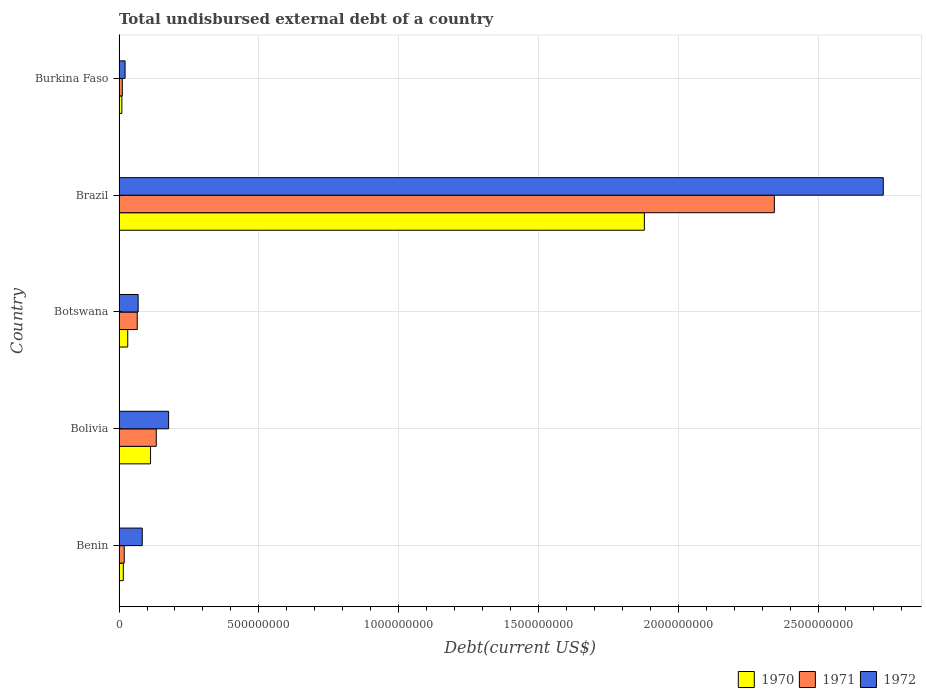How many groups of bars are there?
Provide a short and direct response. 5. Are the number of bars on each tick of the Y-axis equal?
Ensure brevity in your answer.  Yes. What is the label of the 3rd group of bars from the top?
Provide a short and direct response. Botswana. In how many cases, is the number of bars for a given country not equal to the number of legend labels?
Offer a very short reply. 0. What is the total undisbursed external debt in 1970 in Bolivia?
Your answer should be compact. 1.13e+08. Across all countries, what is the maximum total undisbursed external debt in 1972?
Offer a very short reply. 2.73e+09. Across all countries, what is the minimum total undisbursed external debt in 1970?
Offer a very short reply. 1.01e+07. In which country was the total undisbursed external debt in 1972 minimum?
Offer a very short reply. Burkina Faso. What is the total total undisbursed external debt in 1972 in the graph?
Offer a very short reply. 3.08e+09. What is the difference between the total undisbursed external debt in 1971 in Benin and that in Bolivia?
Your answer should be very brief. -1.15e+08. What is the difference between the total undisbursed external debt in 1972 in Benin and the total undisbursed external debt in 1971 in Brazil?
Ensure brevity in your answer.  -2.26e+09. What is the average total undisbursed external debt in 1971 per country?
Provide a short and direct response. 5.14e+08. What is the difference between the total undisbursed external debt in 1970 and total undisbursed external debt in 1971 in Bolivia?
Provide a succinct answer. -2.06e+07. In how many countries, is the total undisbursed external debt in 1972 greater than 2300000000 US$?
Offer a very short reply. 1. What is the ratio of the total undisbursed external debt in 1972 in Benin to that in Burkina Faso?
Ensure brevity in your answer.  3.85. Is the total undisbursed external debt in 1972 in Botswana less than that in Burkina Faso?
Offer a terse response. No. Is the difference between the total undisbursed external debt in 1970 in Bolivia and Burkina Faso greater than the difference between the total undisbursed external debt in 1971 in Bolivia and Burkina Faso?
Make the answer very short. No. What is the difference between the highest and the second highest total undisbursed external debt in 1972?
Keep it short and to the point. 2.56e+09. What is the difference between the highest and the lowest total undisbursed external debt in 1972?
Provide a succinct answer. 2.71e+09. What does the 1st bar from the bottom in Burkina Faso represents?
Your answer should be compact. 1970. How many bars are there?
Offer a very short reply. 15. Are all the bars in the graph horizontal?
Offer a very short reply. Yes. How many countries are there in the graph?
Provide a short and direct response. 5. What is the difference between two consecutive major ticks on the X-axis?
Provide a succinct answer. 5.00e+08. Does the graph contain grids?
Give a very brief answer. Yes. Where does the legend appear in the graph?
Your response must be concise. Bottom right. How many legend labels are there?
Provide a short and direct response. 3. What is the title of the graph?
Give a very brief answer. Total undisbursed external debt of a country. What is the label or title of the X-axis?
Your answer should be compact. Debt(current US$). What is the label or title of the Y-axis?
Offer a terse response. Country. What is the Debt(current US$) in 1970 in Benin?
Offer a very short reply. 1.53e+07. What is the Debt(current US$) in 1971 in Benin?
Provide a succinct answer. 1.85e+07. What is the Debt(current US$) in 1972 in Benin?
Provide a succinct answer. 8.30e+07. What is the Debt(current US$) in 1970 in Bolivia?
Offer a very short reply. 1.13e+08. What is the Debt(current US$) of 1971 in Bolivia?
Give a very brief answer. 1.33e+08. What is the Debt(current US$) of 1972 in Bolivia?
Keep it short and to the point. 1.77e+08. What is the Debt(current US$) of 1970 in Botswana?
Provide a succinct answer. 3.11e+07. What is the Debt(current US$) of 1971 in Botswana?
Make the answer very short. 6.50e+07. What is the Debt(current US$) in 1972 in Botswana?
Your answer should be very brief. 6.83e+07. What is the Debt(current US$) of 1970 in Brazil?
Ensure brevity in your answer.  1.88e+09. What is the Debt(current US$) of 1971 in Brazil?
Give a very brief answer. 2.34e+09. What is the Debt(current US$) in 1972 in Brazil?
Offer a terse response. 2.73e+09. What is the Debt(current US$) in 1970 in Burkina Faso?
Keep it short and to the point. 1.01e+07. What is the Debt(current US$) of 1971 in Burkina Faso?
Keep it short and to the point. 1.16e+07. What is the Debt(current US$) in 1972 in Burkina Faso?
Offer a terse response. 2.16e+07. Across all countries, what is the maximum Debt(current US$) in 1970?
Your answer should be compact. 1.88e+09. Across all countries, what is the maximum Debt(current US$) of 1971?
Ensure brevity in your answer.  2.34e+09. Across all countries, what is the maximum Debt(current US$) in 1972?
Your answer should be very brief. 2.73e+09. Across all countries, what is the minimum Debt(current US$) in 1970?
Provide a short and direct response. 1.01e+07. Across all countries, what is the minimum Debt(current US$) of 1971?
Offer a terse response. 1.16e+07. Across all countries, what is the minimum Debt(current US$) of 1972?
Your answer should be very brief. 2.16e+07. What is the total Debt(current US$) of 1970 in the graph?
Keep it short and to the point. 2.05e+09. What is the total Debt(current US$) in 1971 in the graph?
Your answer should be very brief. 2.57e+09. What is the total Debt(current US$) of 1972 in the graph?
Keep it short and to the point. 3.08e+09. What is the difference between the Debt(current US$) in 1970 in Benin and that in Bolivia?
Ensure brevity in your answer.  -9.73e+07. What is the difference between the Debt(current US$) in 1971 in Benin and that in Bolivia?
Provide a succinct answer. -1.15e+08. What is the difference between the Debt(current US$) of 1972 in Benin and that in Bolivia?
Offer a very short reply. -9.43e+07. What is the difference between the Debt(current US$) in 1970 in Benin and that in Botswana?
Make the answer very short. -1.58e+07. What is the difference between the Debt(current US$) of 1971 in Benin and that in Botswana?
Ensure brevity in your answer.  -4.65e+07. What is the difference between the Debt(current US$) of 1972 in Benin and that in Botswana?
Offer a very short reply. 1.47e+07. What is the difference between the Debt(current US$) in 1970 in Benin and that in Brazil?
Your answer should be compact. -1.86e+09. What is the difference between the Debt(current US$) in 1971 in Benin and that in Brazil?
Offer a terse response. -2.33e+09. What is the difference between the Debt(current US$) in 1972 in Benin and that in Brazil?
Your response must be concise. -2.65e+09. What is the difference between the Debt(current US$) in 1970 in Benin and that in Burkina Faso?
Offer a terse response. 5.22e+06. What is the difference between the Debt(current US$) in 1971 in Benin and that in Burkina Faso?
Offer a terse response. 6.86e+06. What is the difference between the Debt(current US$) in 1972 in Benin and that in Burkina Faso?
Make the answer very short. 6.14e+07. What is the difference between the Debt(current US$) in 1970 in Bolivia and that in Botswana?
Provide a short and direct response. 8.15e+07. What is the difference between the Debt(current US$) in 1971 in Bolivia and that in Botswana?
Give a very brief answer. 6.82e+07. What is the difference between the Debt(current US$) of 1972 in Bolivia and that in Botswana?
Ensure brevity in your answer.  1.09e+08. What is the difference between the Debt(current US$) in 1970 in Bolivia and that in Brazil?
Your answer should be very brief. -1.77e+09. What is the difference between the Debt(current US$) of 1971 in Bolivia and that in Brazil?
Give a very brief answer. -2.21e+09. What is the difference between the Debt(current US$) of 1972 in Bolivia and that in Brazil?
Give a very brief answer. -2.56e+09. What is the difference between the Debt(current US$) in 1970 in Bolivia and that in Burkina Faso?
Ensure brevity in your answer.  1.03e+08. What is the difference between the Debt(current US$) in 1971 in Bolivia and that in Burkina Faso?
Offer a very short reply. 1.22e+08. What is the difference between the Debt(current US$) of 1972 in Bolivia and that in Burkina Faso?
Your answer should be compact. 1.56e+08. What is the difference between the Debt(current US$) of 1970 in Botswana and that in Brazil?
Ensure brevity in your answer.  -1.85e+09. What is the difference between the Debt(current US$) in 1971 in Botswana and that in Brazil?
Your response must be concise. -2.28e+09. What is the difference between the Debt(current US$) in 1972 in Botswana and that in Brazil?
Provide a short and direct response. -2.67e+09. What is the difference between the Debt(current US$) of 1970 in Botswana and that in Burkina Faso?
Your response must be concise. 2.10e+07. What is the difference between the Debt(current US$) of 1971 in Botswana and that in Burkina Faso?
Keep it short and to the point. 5.34e+07. What is the difference between the Debt(current US$) in 1972 in Botswana and that in Burkina Faso?
Offer a terse response. 4.67e+07. What is the difference between the Debt(current US$) of 1970 in Brazil and that in Burkina Faso?
Ensure brevity in your answer.  1.87e+09. What is the difference between the Debt(current US$) in 1971 in Brazil and that in Burkina Faso?
Offer a very short reply. 2.33e+09. What is the difference between the Debt(current US$) in 1972 in Brazil and that in Burkina Faso?
Ensure brevity in your answer.  2.71e+09. What is the difference between the Debt(current US$) of 1970 in Benin and the Debt(current US$) of 1971 in Bolivia?
Your response must be concise. -1.18e+08. What is the difference between the Debt(current US$) of 1970 in Benin and the Debt(current US$) of 1972 in Bolivia?
Make the answer very short. -1.62e+08. What is the difference between the Debt(current US$) in 1971 in Benin and the Debt(current US$) in 1972 in Bolivia?
Your response must be concise. -1.59e+08. What is the difference between the Debt(current US$) of 1970 in Benin and the Debt(current US$) of 1971 in Botswana?
Keep it short and to the point. -4.97e+07. What is the difference between the Debt(current US$) of 1970 in Benin and the Debt(current US$) of 1972 in Botswana?
Ensure brevity in your answer.  -5.30e+07. What is the difference between the Debt(current US$) in 1971 in Benin and the Debt(current US$) in 1972 in Botswana?
Ensure brevity in your answer.  -4.98e+07. What is the difference between the Debt(current US$) in 1970 in Benin and the Debt(current US$) in 1971 in Brazil?
Make the answer very short. -2.33e+09. What is the difference between the Debt(current US$) of 1970 in Benin and the Debt(current US$) of 1972 in Brazil?
Offer a terse response. -2.72e+09. What is the difference between the Debt(current US$) of 1971 in Benin and the Debt(current US$) of 1972 in Brazil?
Keep it short and to the point. -2.72e+09. What is the difference between the Debt(current US$) in 1970 in Benin and the Debt(current US$) in 1971 in Burkina Faso?
Your answer should be compact. 3.65e+06. What is the difference between the Debt(current US$) of 1970 in Benin and the Debt(current US$) of 1972 in Burkina Faso?
Your answer should be very brief. -6.29e+06. What is the difference between the Debt(current US$) of 1971 in Benin and the Debt(current US$) of 1972 in Burkina Faso?
Offer a very short reply. -3.08e+06. What is the difference between the Debt(current US$) in 1970 in Bolivia and the Debt(current US$) in 1971 in Botswana?
Offer a very short reply. 4.76e+07. What is the difference between the Debt(current US$) in 1970 in Bolivia and the Debt(current US$) in 1972 in Botswana?
Provide a succinct answer. 4.43e+07. What is the difference between the Debt(current US$) in 1971 in Bolivia and the Debt(current US$) in 1972 in Botswana?
Your answer should be compact. 6.49e+07. What is the difference between the Debt(current US$) in 1970 in Bolivia and the Debt(current US$) in 1971 in Brazil?
Ensure brevity in your answer.  -2.23e+09. What is the difference between the Debt(current US$) of 1970 in Bolivia and the Debt(current US$) of 1972 in Brazil?
Your answer should be compact. -2.62e+09. What is the difference between the Debt(current US$) of 1971 in Bolivia and the Debt(current US$) of 1972 in Brazil?
Provide a succinct answer. -2.60e+09. What is the difference between the Debt(current US$) in 1970 in Bolivia and the Debt(current US$) in 1971 in Burkina Faso?
Ensure brevity in your answer.  1.01e+08. What is the difference between the Debt(current US$) in 1970 in Bolivia and the Debt(current US$) in 1972 in Burkina Faso?
Offer a terse response. 9.10e+07. What is the difference between the Debt(current US$) of 1971 in Bolivia and the Debt(current US$) of 1972 in Burkina Faso?
Ensure brevity in your answer.  1.12e+08. What is the difference between the Debt(current US$) of 1970 in Botswana and the Debt(current US$) of 1971 in Brazil?
Your answer should be compact. -2.31e+09. What is the difference between the Debt(current US$) in 1970 in Botswana and the Debt(current US$) in 1972 in Brazil?
Make the answer very short. -2.70e+09. What is the difference between the Debt(current US$) of 1971 in Botswana and the Debt(current US$) of 1972 in Brazil?
Provide a succinct answer. -2.67e+09. What is the difference between the Debt(current US$) of 1970 in Botswana and the Debt(current US$) of 1971 in Burkina Faso?
Give a very brief answer. 1.94e+07. What is the difference between the Debt(current US$) of 1970 in Botswana and the Debt(current US$) of 1972 in Burkina Faso?
Offer a very short reply. 9.50e+06. What is the difference between the Debt(current US$) of 1971 in Botswana and the Debt(current US$) of 1972 in Burkina Faso?
Keep it short and to the point. 4.34e+07. What is the difference between the Debt(current US$) in 1970 in Brazil and the Debt(current US$) in 1971 in Burkina Faso?
Give a very brief answer. 1.87e+09. What is the difference between the Debt(current US$) in 1970 in Brazil and the Debt(current US$) in 1972 in Burkina Faso?
Give a very brief answer. 1.86e+09. What is the difference between the Debt(current US$) of 1971 in Brazil and the Debt(current US$) of 1972 in Burkina Faso?
Give a very brief answer. 2.32e+09. What is the average Debt(current US$) in 1970 per country?
Give a very brief answer. 4.10e+08. What is the average Debt(current US$) of 1971 per country?
Your answer should be very brief. 5.14e+08. What is the average Debt(current US$) in 1972 per country?
Keep it short and to the point. 6.17e+08. What is the difference between the Debt(current US$) of 1970 and Debt(current US$) of 1971 in Benin?
Offer a very short reply. -3.21e+06. What is the difference between the Debt(current US$) of 1970 and Debt(current US$) of 1972 in Benin?
Give a very brief answer. -6.77e+07. What is the difference between the Debt(current US$) of 1971 and Debt(current US$) of 1972 in Benin?
Your answer should be very brief. -6.45e+07. What is the difference between the Debt(current US$) in 1970 and Debt(current US$) in 1971 in Bolivia?
Give a very brief answer. -2.06e+07. What is the difference between the Debt(current US$) of 1970 and Debt(current US$) of 1972 in Bolivia?
Provide a short and direct response. -6.47e+07. What is the difference between the Debt(current US$) of 1971 and Debt(current US$) of 1972 in Bolivia?
Your answer should be very brief. -4.41e+07. What is the difference between the Debt(current US$) of 1970 and Debt(current US$) of 1971 in Botswana?
Keep it short and to the point. -3.39e+07. What is the difference between the Debt(current US$) of 1970 and Debt(current US$) of 1972 in Botswana?
Offer a very short reply. -3.72e+07. What is the difference between the Debt(current US$) in 1971 and Debt(current US$) in 1972 in Botswana?
Give a very brief answer. -3.24e+06. What is the difference between the Debt(current US$) of 1970 and Debt(current US$) of 1971 in Brazil?
Offer a very short reply. -4.65e+08. What is the difference between the Debt(current US$) in 1970 and Debt(current US$) in 1972 in Brazil?
Your response must be concise. -8.55e+08. What is the difference between the Debt(current US$) in 1971 and Debt(current US$) in 1972 in Brazil?
Make the answer very short. -3.90e+08. What is the difference between the Debt(current US$) in 1970 and Debt(current US$) in 1971 in Burkina Faso?
Your answer should be very brief. -1.58e+06. What is the difference between the Debt(current US$) of 1970 and Debt(current US$) of 1972 in Burkina Faso?
Give a very brief answer. -1.15e+07. What is the difference between the Debt(current US$) in 1971 and Debt(current US$) in 1972 in Burkina Faso?
Offer a terse response. -9.93e+06. What is the ratio of the Debt(current US$) in 1970 in Benin to that in Bolivia?
Your response must be concise. 0.14. What is the ratio of the Debt(current US$) of 1971 in Benin to that in Bolivia?
Your answer should be compact. 0.14. What is the ratio of the Debt(current US$) of 1972 in Benin to that in Bolivia?
Give a very brief answer. 0.47. What is the ratio of the Debt(current US$) of 1970 in Benin to that in Botswana?
Your answer should be very brief. 0.49. What is the ratio of the Debt(current US$) in 1971 in Benin to that in Botswana?
Provide a short and direct response. 0.28. What is the ratio of the Debt(current US$) of 1972 in Benin to that in Botswana?
Provide a short and direct response. 1.22. What is the ratio of the Debt(current US$) in 1970 in Benin to that in Brazil?
Offer a terse response. 0.01. What is the ratio of the Debt(current US$) of 1971 in Benin to that in Brazil?
Provide a succinct answer. 0.01. What is the ratio of the Debt(current US$) in 1972 in Benin to that in Brazil?
Offer a very short reply. 0.03. What is the ratio of the Debt(current US$) of 1970 in Benin to that in Burkina Faso?
Ensure brevity in your answer.  1.52. What is the ratio of the Debt(current US$) in 1971 in Benin to that in Burkina Faso?
Make the answer very short. 1.59. What is the ratio of the Debt(current US$) in 1972 in Benin to that in Burkina Faso?
Your answer should be very brief. 3.85. What is the ratio of the Debt(current US$) of 1970 in Bolivia to that in Botswana?
Ensure brevity in your answer.  3.62. What is the ratio of the Debt(current US$) in 1971 in Bolivia to that in Botswana?
Your response must be concise. 2.05. What is the ratio of the Debt(current US$) of 1972 in Bolivia to that in Botswana?
Make the answer very short. 2.6. What is the ratio of the Debt(current US$) in 1970 in Bolivia to that in Brazil?
Your response must be concise. 0.06. What is the ratio of the Debt(current US$) in 1971 in Bolivia to that in Brazil?
Provide a short and direct response. 0.06. What is the ratio of the Debt(current US$) in 1972 in Bolivia to that in Brazil?
Provide a succinct answer. 0.06. What is the ratio of the Debt(current US$) in 1970 in Bolivia to that in Burkina Faso?
Offer a terse response. 11.19. What is the ratio of the Debt(current US$) of 1971 in Bolivia to that in Burkina Faso?
Offer a very short reply. 11.44. What is the ratio of the Debt(current US$) in 1972 in Bolivia to that in Burkina Faso?
Make the answer very short. 8.22. What is the ratio of the Debt(current US$) of 1970 in Botswana to that in Brazil?
Provide a short and direct response. 0.02. What is the ratio of the Debt(current US$) of 1971 in Botswana to that in Brazil?
Offer a terse response. 0.03. What is the ratio of the Debt(current US$) of 1972 in Botswana to that in Brazil?
Make the answer very short. 0.03. What is the ratio of the Debt(current US$) of 1970 in Botswana to that in Burkina Faso?
Provide a succinct answer. 3.09. What is the ratio of the Debt(current US$) in 1971 in Botswana to that in Burkina Faso?
Provide a short and direct response. 5.58. What is the ratio of the Debt(current US$) of 1972 in Botswana to that in Burkina Faso?
Your response must be concise. 3.16. What is the ratio of the Debt(current US$) in 1970 in Brazil to that in Burkina Faso?
Your response must be concise. 186.68. What is the ratio of the Debt(current US$) of 1971 in Brazil to that in Burkina Faso?
Keep it short and to the point. 201.33. What is the ratio of the Debt(current US$) of 1972 in Brazil to that in Burkina Faso?
Provide a succinct answer. 126.69. What is the difference between the highest and the second highest Debt(current US$) of 1970?
Keep it short and to the point. 1.77e+09. What is the difference between the highest and the second highest Debt(current US$) in 1971?
Give a very brief answer. 2.21e+09. What is the difference between the highest and the second highest Debt(current US$) of 1972?
Offer a terse response. 2.56e+09. What is the difference between the highest and the lowest Debt(current US$) in 1970?
Offer a very short reply. 1.87e+09. What is the difference between the highest and the lowest Debt(current US$) in 1971?
Your answer should be compact. 2.33e+09. What is the difference between the highest and the lowest Debt(current US$) of 1972?
Keep it short and to the point. 2.71e+09. 